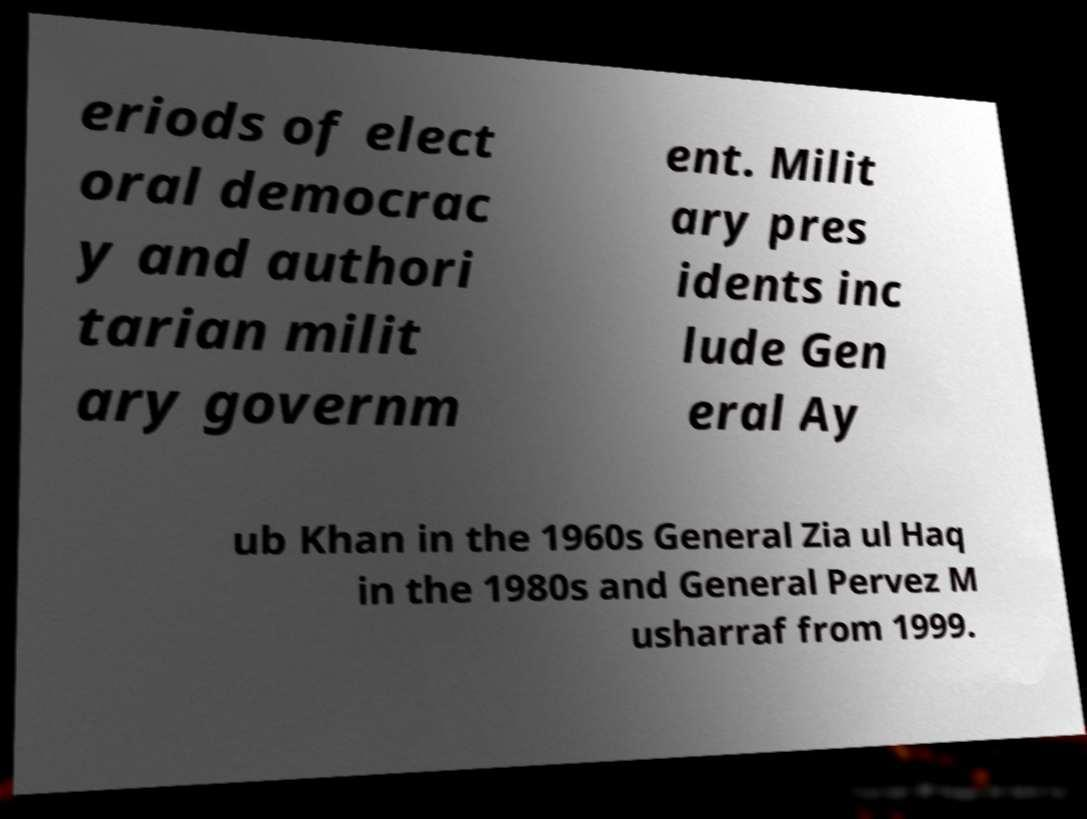For documentation purposes, I need the text within this image transcribed. Could you provide that? eriods of elect oral democrac y and authori tarian milit ary governm ent. Milit ary pres idents inc lude Gen eral Ay ub Khan in the 1960s General Zia ul Haq in the 1980s and General Pervez M usharraf from 1999. 